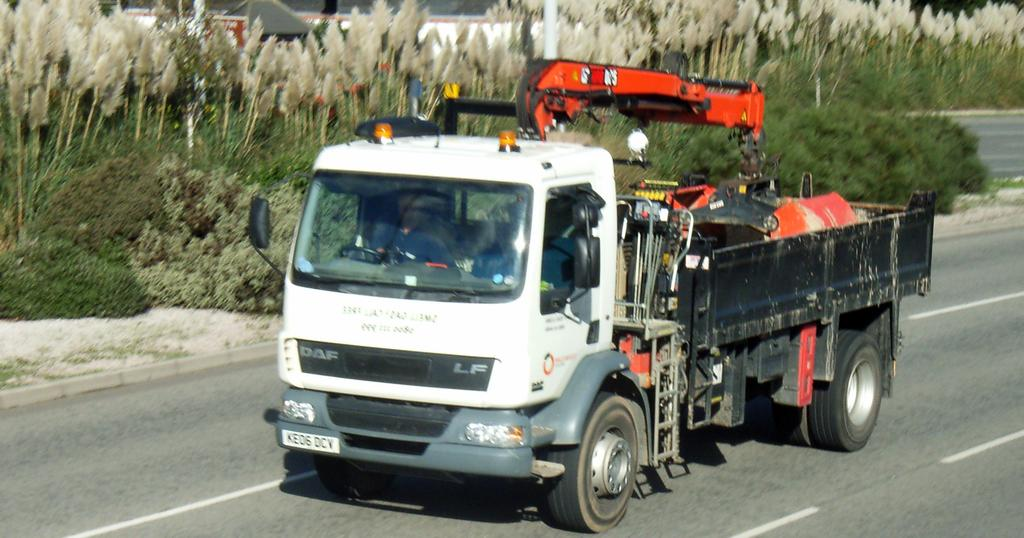What type of motor vehicle is in the image? There is a motor vehicle in the image, but the specific type is not mentioned. Who or what is inside the motor vehicle? There is a person in the motor vehicle. What is the setting of the image? There is a road, trees, and shrubs visible in the image. What part of the natural environment can be seen in the image? The ground is visible in the image. Can you see a clam walking along the road in the image? No, there is no clam or any indication of a clam walking along the road in the image. Is the person's grandmother also present in the motor vehicle? There is no mention of a grandmother or any other person in the image, only the presence of a person in the motor vehicle. 